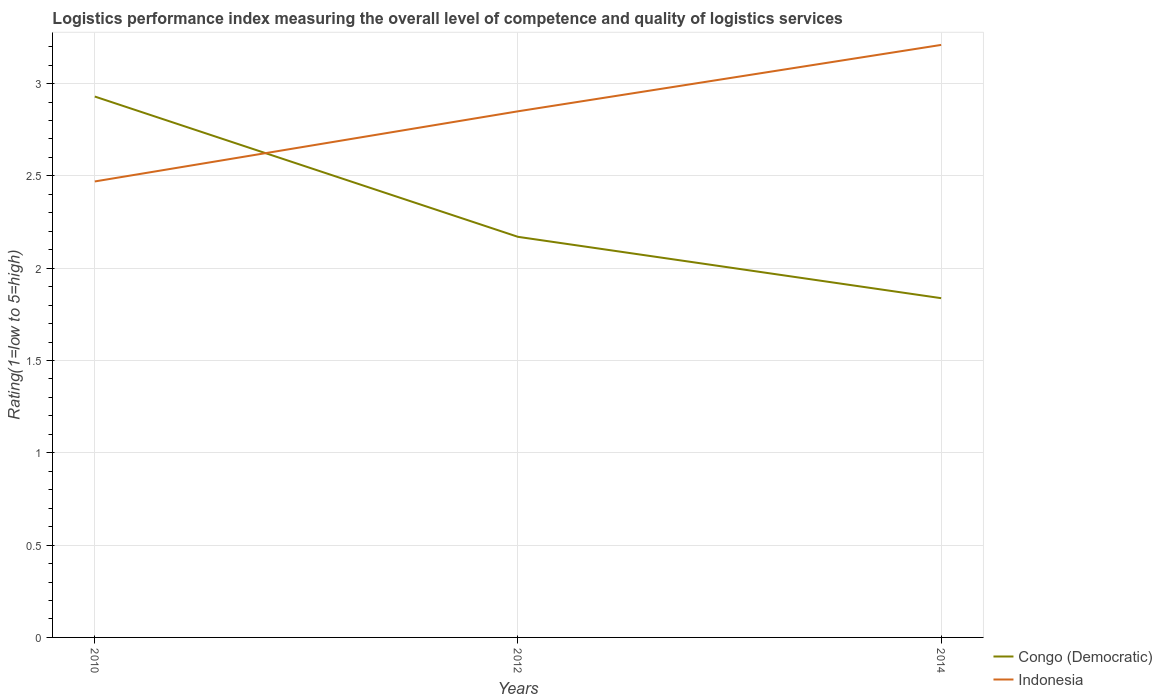How many different coloured lines are there?
Ensure brevity in your answer.  2. Is the number of lines equal to the number of legend labels?
Ensure brevity in your answer.  Yes. Across all years, what is the maximum Logistic performance index in Indonesia?
Keep it short and to the point. 2.47. In which year was the Logistic performance index in Congo (Democratic) maximum?
Make the answer very short. 2014. What is the total Logistic performance index in Indonesia in the graph?
Provide a succinct answer. -0.38. What is the difference between the highest and the second highest Logistic performance index in Indonesia?
Provide a short and direct response. 0.74. What is the difference between the highest and the lowest Logistic performance index in Indonesia?
Provide a short and direct response. 2. Is the Logistic performance index in Congo (Democratic) strictly greater than the Logistic performance index in Indonesia over the years?
Ensure brevity in your answer.  No. How many lines are there?
Ensure brevity in your answer.  2. Are the values on the major ticks of Y-axis written in scientific E-notation?
Your response must be concise. No. Does the graph contain any zero values?
Make the answer very short. No. Where does the legend appear in the graph?
Offer a terse response. Bottom right. How are the legend labels stacked?
Make the answer very short. Vertical. What is the title of the graph?
Offer a very short reply. Logistics performance index measuring the overall level of competence and quality of logistics services. Does "Burkina Faso" appear as one of the legend labels in the graph?
Ensure brevity in your answer.  No. What is the label or title of the Y-axis?
Provide a succinct answer. Rating(1=low to 5=high). What is the Rating(1=low to 5=high) in Congo (Democratic) in 2010?
Your response must be concise. 2.93. What is the Rating(1=low to 5=high) of Indonesia in 2010?
Provide a short and direct response. 2.47. What is the Rating(1=low to 5=high) in Congo (Democratic) in 2012?
Your response must be concise. 2.17. What is the Rating(1=low to 5=high) of Indonesia in 2012?
Ensure brevity in your answer.  2.85. What is the Rating(1=low to 5=high) of Congo (Democratic) in 2014?
Your response must be concise. 1.84. What is the Rating(1=low to 5=high) of Indonesia in 2014?
Your response must be concise. 3.21. Across all years, what is the maximum Rating(1=low to 5=high) in Congo (Democratic)?
Provide a short and direct response. 2.93. Across all years, what is the maximum Rating(1=low to 5=high) of Indonesia?
Provide a succinct answer. 3.21. Across all years, what is the minimum Rating(1=low to 5=high) of Congo (Democratic)?
Offer a very short reply. 1.84. Across all years, what is the minimum Rating(1=low to 5=high) in Indonesia?
Ensure brevity in your answer.  2.47. What is the total Rating(1=low to 5=high) of Congo (Democratic) in the graph?
Keep it short and to the point. 6.94. What is the total Rating(1=low to 5=high) of Indonesia in the graph?
Offer a very short reply. 8.53. What is the difference between the Rating(1=low to 5=high) of Congo (Democratic) in 2010 and that in 2012?
Provide a succinct answer. 0.76. What is the difference between the Rating(1=low to 5=high) in Indonesia in 2010 and that in 2012?
Offer a very short reply. -0.38. What is the difference between the Rating(1=low to 5=high) in Congo (Democratic) in 2010 and that in 2014?
Give a very brief answer. 1.09. What is the difference between the Rating(1=low to 5=high) in Indonesia in 2010 and that in 2014?
Your answer should be very brief. -0.74. What is the difference between the Rating(1=low to 5=high) of Congo (Democratic) in 2012 and that in 2014?
Keep it short and to the point. 0.33. What is the difference between the Rating(1=low to 5=high) of Indonesia in 2012 and that in 2014?
Ensure brevity in your answer.  -0.36. What is the difference between the Rating(1=low to 5=high) in Congo (Democratic) in 2010 and the Rating(1=low to 5=high) in Indonesia in 2014?
Your answer should be compact. -0.28. What is the difference between the Rating(1=low to 5=high) of Congo (Democratic) in 2012 and the Rating(1=low to 5=high) of Indonesia in 2014?
Offer a terse response. -1.04. What is the average Rating(1=low to 5=high) of Congo (Democratic) per year?
Provide a succinct answer. 2.31. What is the average Rating(1=low to 5=high) in Indonesia per year?
Offer a terse response. 2.84. In the year 2010, what is the difference between the Rating(1=low to 5=high) of Congo (Democratic) and Rating(1=low to 5=high) of Indonesia?
Offer a very short reply. 0.46. In the year 2012, what is the difference between the Rating(1=low to 5=high) of Congo (Democratic) and Rating(1=low to 5=high) of Indonesia?
Keep it short and to the point. -0.68. In the year 2014, what is the difference between the Rating(1=low to 5=high) of Congo (Democratic) and Rating(1=low to 5=high) of Indonesia?
Offer a terse response. -1.37. What is the ratio of the Rating(1=low to 5=high) in Congo (Democratic) in 2010 to that in 2012?
Provide a succinct answer. 1.35. What is the ratio of the Rating(1=low to 5=high) in Indonesia in 2010 to that in 2012?
Make the answer very short. 0.87. What is the ratio of the Rating(1=low to 5=high) of Congo (Democratic) in 2010 to that in 2014?
Offer a terse response. 1.59. What is the ratio of the Rating(1=low to 5=high) of Indonesia in 2010 to that in 2014?
Offer a very short reply. 0.77. What is the ratio of the Rating(1=low to 5=high) in Congo (Democratic) in 2012 to that in 2014?
Make the answer very short. 1.18. What is the ratio of the Rating(1=low to 5=high) of Indonesia in 2012 to that in 2014?
Your answer should be compact. 0.89. What is the difference between the highest and the second highest Rating(1=low to 5=high) of Congo (Democratic)?
Ensure brevity in your answer.  0.76. What is the difference between the highest and the second highest Rating(1=low to 5=high) in Indonesia?
Your answer should be compact. 0.36. What is the difference between the highest and the lowest Rating(1=low to 5=high) of Congo (Democratic)?
Offer a terse response. 1.09. What is the difference between the highest and the lowest Rating(1=low to 5=high) in Indonesia?
Provide a short and direct response. 0.74. 